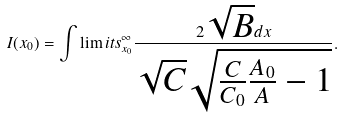<formula> <loc_0><loc_0><loc_500><loc_500>I ( x _ { 0 } ) = \int \lim i t s _ { x _ { 0 } } ^ { \infty } \frac { 2 \sqrt { B } d x } { \sqrt { C } \sqrt { \frac { C } { C _ { 0 } } \frac { A _ { 0 } } { A } - 1 } } .</formula> 